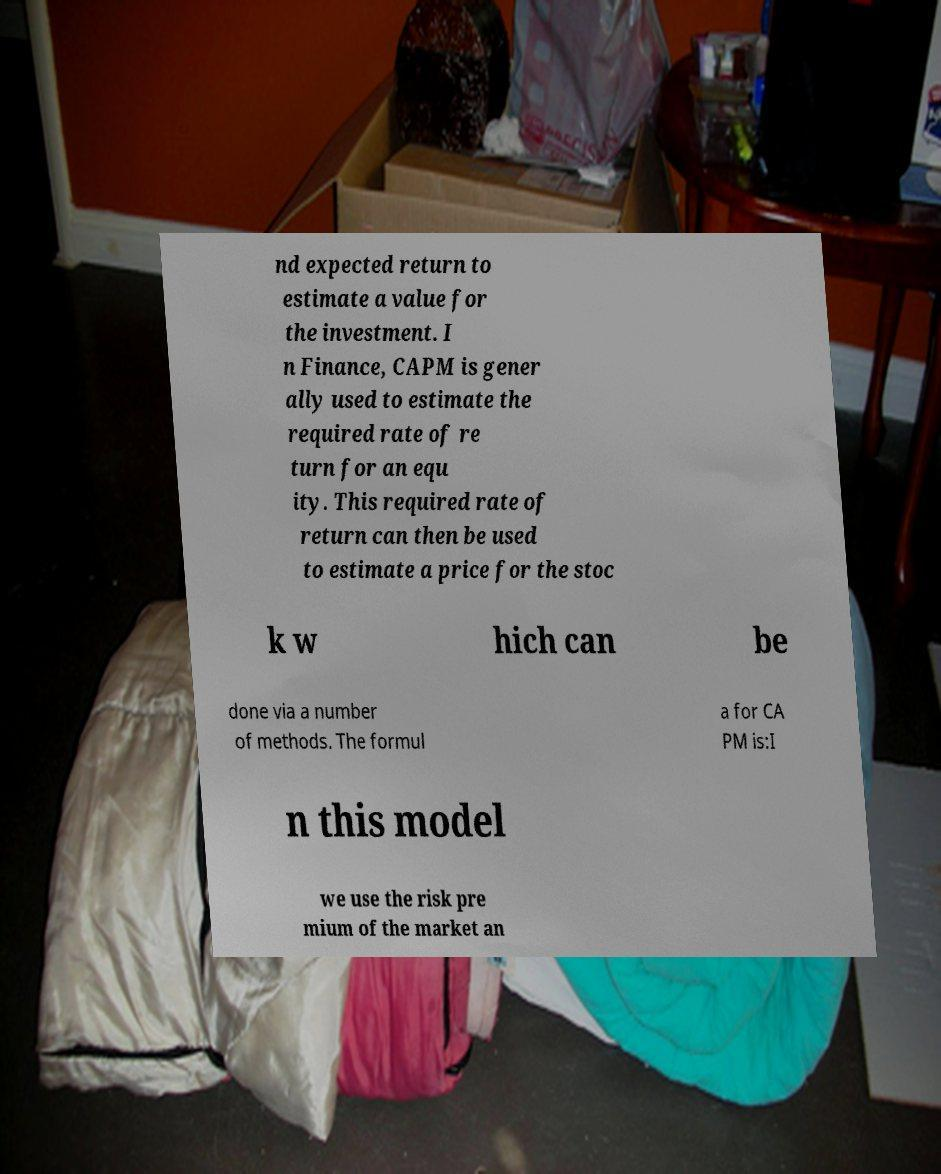What messages or text are displayed in this image? I need them in a readable, typed format. nd expected return to estimate a value for the investment. I n Finance, CAPM is gener ally used to estimate the required rate of re turn for an equ ity. This required rate of return can then be used to estimate a price for the stoc k w hich can be done via a number of methods. The formul a for CA PM is:I n this model we use the risk pre mium of the market an 